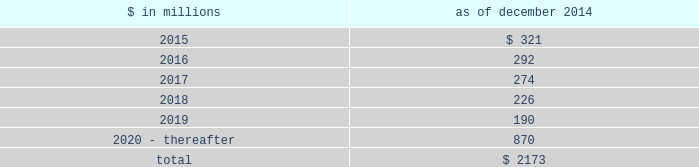Notes to consolidated financial statements sumitomo mitsui financial group , inc .
( smfg ) provides the firm with credit loss protection on certain approved loan commitments ( primarily investment-grade commercial lending commitments ) .
The notional amount of such loan commitments was $ 27.51 billion and $ 29.24 billion as of december 2014 and december 2013 , respectively .
The credit loss protection on loan commitments provided by smfg is generally limited to 95% ( 95 % ) of the first loss the firm realizes on such commitments , up to a maximum of approximately $ 950 million .
In addition , subject to the satisfaction of certain conditions , upon the firm 2019s request , smfg will provide protection for 70% ( 70 % ) of additional losses on such commitments , up to a maximum of $ 1.13 billion , of which $ 768 million and $ 870 million of protection had been provided as of december 2014 and december 2013 , respectively .
The firm also uses other financial instruments to mitigate credit risks related to certain commitments not covered by smfg .
These instruments primarily include credit default swaps that reference the same or similar underlying instrument or entity , or credit default swaps that reference a market index .
Warehouse financing .
The firm provides financing to clients who warehouse financial assets .
These arrangements are secured by the warehoused assets , primarily consisting of corporate loans and commercial mortgage loans .
Contingent and forward starting resale and securities borrowing agreements/forward starting repurchase and secured lending agreements the firm enters into resale and securities borrowing agreements and repurchase and secured lending agreements that settle at a future date , generally within three business days .
The firm also enters into commitments to provide contingent financing to its clients and counterparties through resale agreements .
The firm 2019s funding of these commitments depends on the satisfaction of all contractual conditions to the resale agreement and these commitments can expire unused .
Letters of credit the firm has commitments under letters of credit issued by various banks which the firm provides to counterparties in lieu of securities or cash to satisfy various collateral and margin deposit requirements .
Investment commitments the firm 2019s investment commitments of $ 5.16 billion and $ 7.12 billion as of december 2014 and december 2013 , respectively , include commitments to invest in private equity , real estate and other assets directly and through funds that the firm raises and manages .
Of these amounts , $ 2.87 billion and $ 5.48 billion as of december 2014 and december 2013 , respectively , relate to commitments to invest in funds managed by the firm .
If these commitments are called , they would be funded at market value on the date of investment .
Leases the firm has contractual obligations under long-term noncancelable lease agreements , principally for office space , expiring on various dates through 2069 .
Certain agreements are subject to periodic escalation provisions for increases in real estate taxes and other charges .
The table below presents future minimum rental payments , net of minimum sublease rentals .
$ in millions december 2014 .
Rent charged to operating expense was $ 309 million for 2014 , $ 324 million for 2013 and $ 374 million for 2012 .
Operating leases include office space held in excess of current requirements .
Rent expense relating to space held for growth is included in 201coccupancy . 201d the firm records a liability , based on the fair value of the remaining lease rentals reduced by any potential or existing sublease rentals , for leases where the firm has ceased using the space and management has concluded that the firm will not derive any future economic benefits .
Costs to terminate a lease before the end of its term are recognized and measured at fair value on termination .
Goldman sachs 2014 annual report 165 .
Rent charged to operating expense in millions totaled how much for 2014 and 2013? 
Computations: (309 + 324)
Answer: 633.0. 